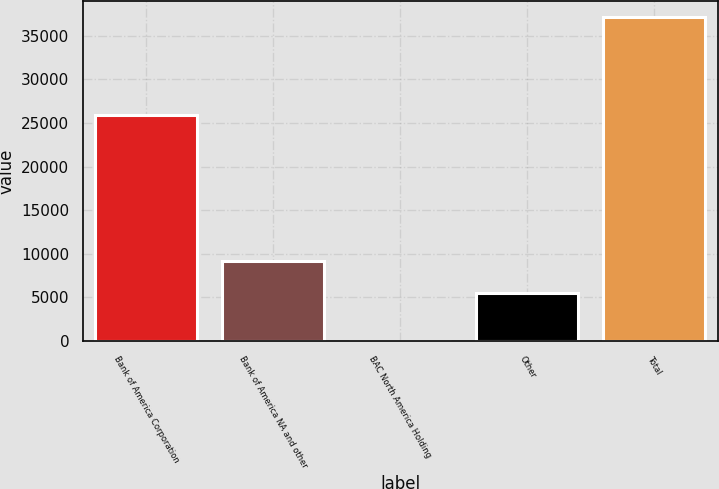Convert chart to OTSL. <chart><loc_0><loc_0><loc_500><loc_500><bar_chart><fcel>Bank of America Corporation<fcel>Bank of America NA and other<fcel>BAC North America Holding<fcel>Other<fcel>Total<nl><fcel>25928<fcel>9198.5<fcel>15<fcel>5490<fcel>37100<nl></chart> 